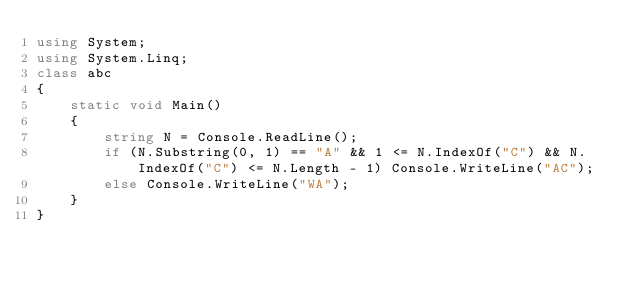<code> <loc_0><loc_0><loc_500><loc_500><_C#_>using System;
using System.Linq;
class abc
{
    static void Main()
    {
        string N = Console.ReadLine();
        if (N.Substring(0, 1) == "A" && 1 <= N.IndexOf("C") && N.IndexOf("C") <= N.Length - 1) Console.WriteLine("AC");
        else Console.WriteLine("WA");
    }
}
</code> 